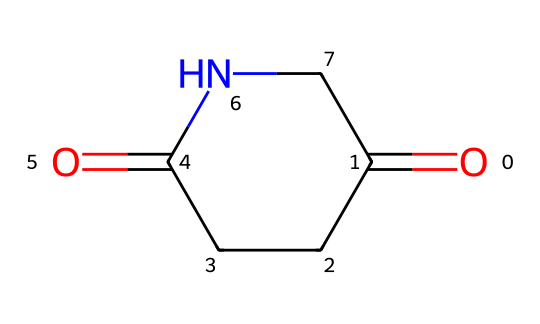What is the IUPAC name of the chemical represented? The chemical SMILES represents an imide structure with a five-membered ring containing one nitrogen and two carbonyl groups. The IUPAC name derived from this structure is glutarimide.
Answer: glutarimide How many carbon atoms are in the molecule? The SMILES representation shows five carbon atoms in total: four in the ring and one in the carbonyl group. Therefore, counting them gives a total of five carbon atoms.
Answer: five What is the number of nitrogen atoms present in the structure? The chemical structure contains one nitrogen atom, which is clearly indicated in the cyclic portion of the SMILES representation.
Answer: one Which functional group characterizes this compound as an imide? The presence of two carbonyl (C=O) groups adjacent to the nitrogen atom defines the imide functional group. In this structure, the carbonyls are directly connected to the nitrogen in the cyclic form.
Answer: carbonyl groups Identify the type of ring structure in glutarimide. Glutarimide contains a five-membered ring, which is characteristic of its molecular structure. The presence of the nitrogen in the ring, along with the carbonyl groups, specifies it as a cyclic imide.
Answer: five-membered ring What is the total number of bonds in the chemical structure? Counting the bonds in the structure: there are eight single bonds (C–C, C–N) and two double bonds (C=O). Therefore, the total number of bonds equals ten.
Answer: ten In what kind of drug formulations might glutarimide be used? Glutarimide is often used in drug formulations related to anticonvulsant or anti-inflammatory properties due to its chemical structure and related effects in medicinal chemistry.
Answer: drug formulations 